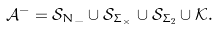<formula> <loc_0><loc_0><loc_500><loc_500>\mathcal { A } ^ { - } = \mathcal { S } _ { N _ { - } } \cup \mathcal { S } _ { \Sigma _ { \times } } \cup \mathcal { S } _ { \Sigma _ { 2 } } \cup \mathcal { K } .</formula> 